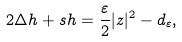Convert formula to latex. <formula><loc_0><loc_0><loc_500><loc_500>2 \Delta h + s h = \frac { \varepsilon } { 2 } | z | ^ { 2 } - d _ { \varepsilon } ,</formula> 